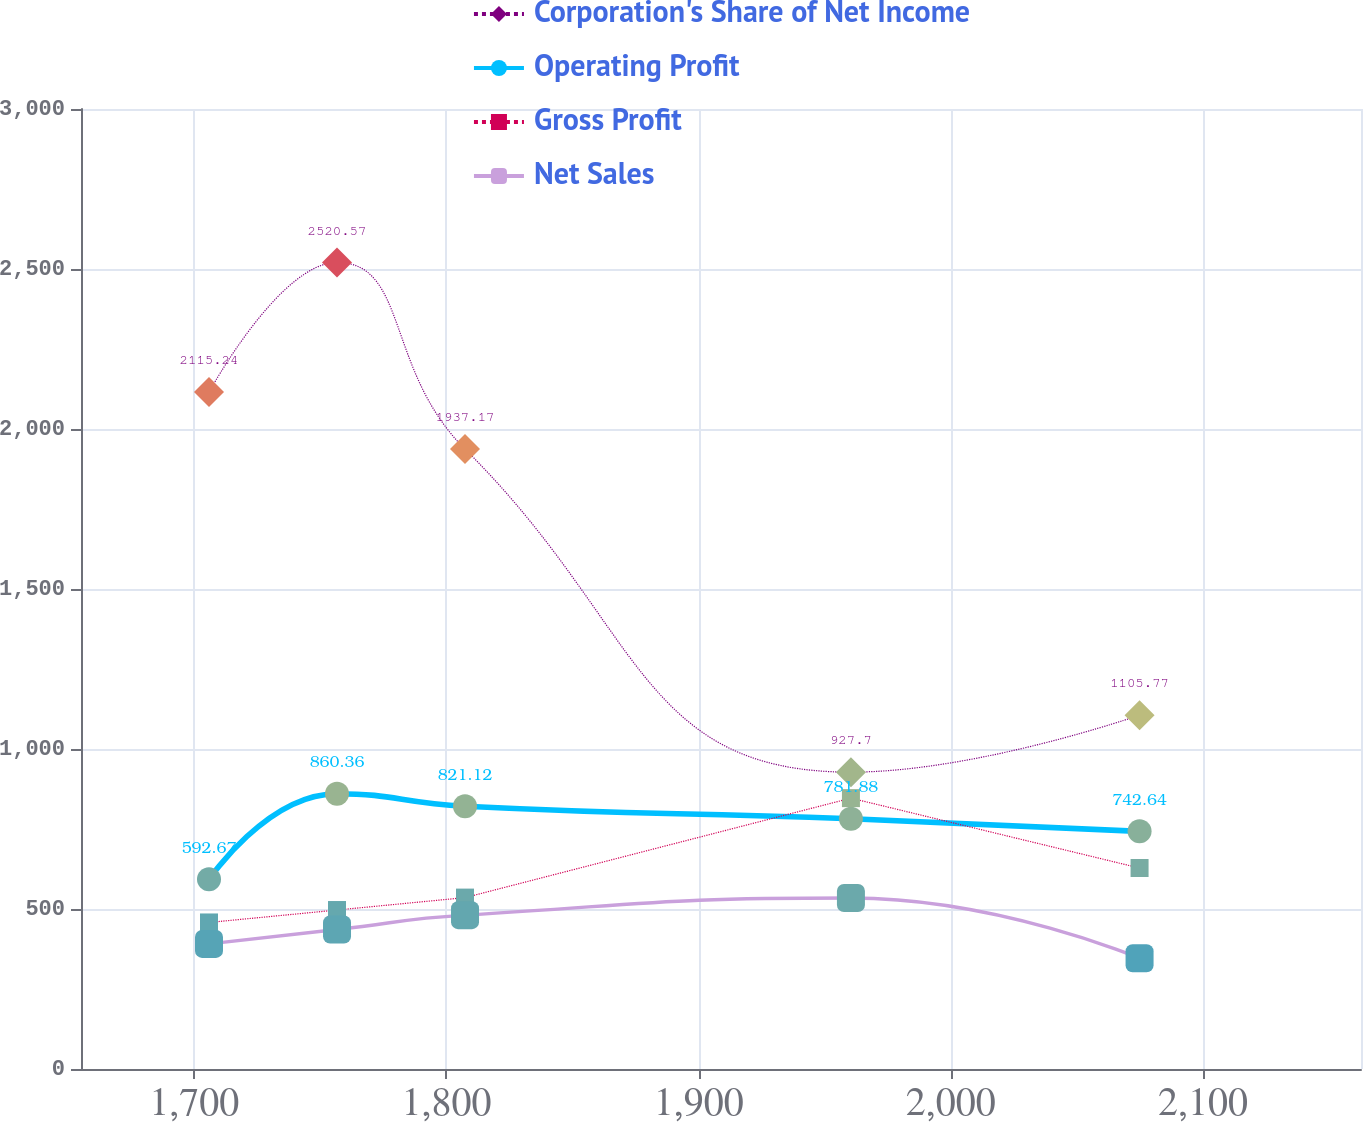Convert chart to OTSL. <chart><loc_0><loc_0><loc_500><loc_500><line_chart><ecel><fcel>Corporation's Share of Net Income<fcel>Operating Profit<fcel>Gross Profit<fcel>Net Sales<nl><fcel>1705.89<fcel>2115.24<fcel>592.67<fcel>457.93<fcel>390.87<nl><fcel>1756.64<fcel>2520.57<fcel>860.36<fcel>496.78<fcel>435.79<nl><fcel>1807.39<fcel>1937.17<fcel>821.12<fcel>535.63<fcel>480.71<nl><fcel>1960.38<fcel>927.7<fcel>781.88<fcel>846.45<fcel>534.17<nl><fcel>2074.81<fcel>1105.77<fcel>742.64<fcel>628.04<fcel>345.95<nl><fcel>2213.34<fcel>739.85<fcel>985.11<fcel>574.48<fcel>795.11<nl></chart> 